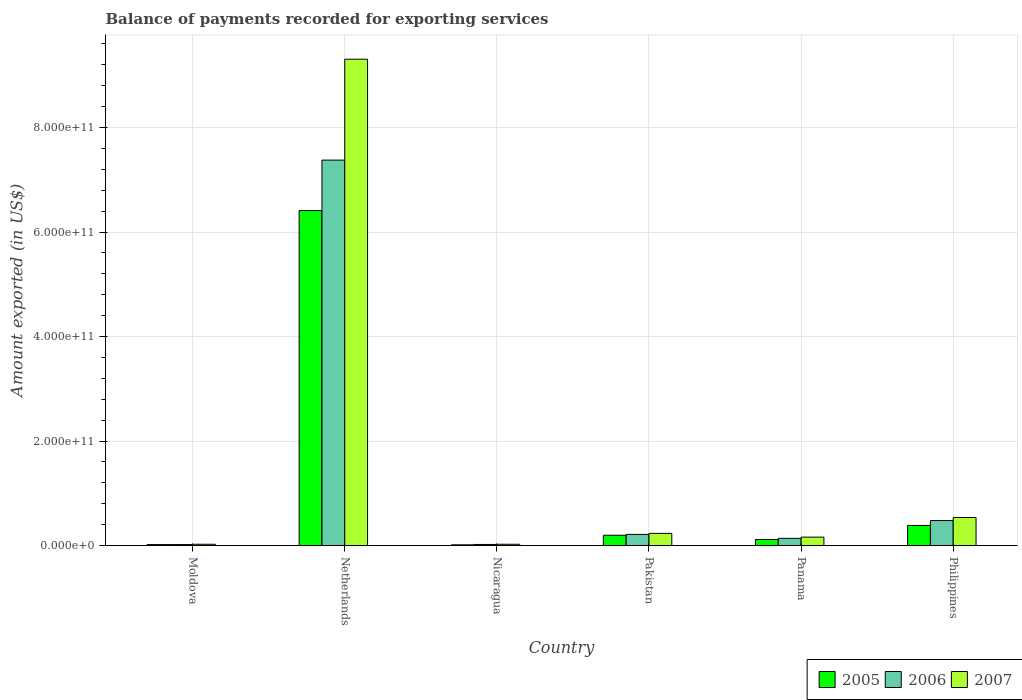How many groups of bars are there?
Make the answer very short. 6. Are the number of bars per tick equal to the number of legend labels?
Make the answer very short. Yes. Are the number of bars on each tick of the X-axis equal?
Ensure brevity in your answer.  Yes. What is the label of the 1st group of bars from the left?
Keep it short and to the point. Moldova. What is the amount exported in 2005 in Netherlands?
Ensure brevity in your answer.  6.41e+11. Across all countries, what is the maximum amount exported in 2006?
Keep it short and to the point. 7.38e+11. Across all countries, what is the minimum amount exported in 2007?
Offer a very short reply. 2.46e+09. In which country was the amount exported in 2007 maximum?
Offer a very short reply. Netherlands. In which country was the amount exported in 2005 minimum?
Keep it short and to the point. Nicaragua. What is the total amount exported in 2005 in the graph?
Provide a short and direct response. 7.14e+11. What is the difference between the amount exported in 2006 in Pakistan and that in Philippines?
Provide a short and direct response. -2.65e+1. What is the difference between the amount exported in 2006 in Nicaragua and the amount exported in 2005 in Moldova?
Your answer should be compact. 2.25e+08. What is the average amount exported in 2006 per country?
Offer a terse response. 1.37e+11. What is the difference between the amount exported of/in 2006 and amount exported of/in 2007 in Nicaragua?
Give a very brief answer. -3.72e+08. In how many countries, is the amount exported in 2007 greater than 40000000000 US$?
Make the answer very short. 2. What is the ratio of the amount exported in 2005 in Pakistan to that in Philippines?
Make the answer very short. 0.51. What is the difference between the highest and the second highest amount exported in 2007?
Offer a very short reply. 8.77e+11. What is the difference between the highest and the lowest amount exported in 2007?
Make the answer very short. 9.28e+11. In how many countries, is the amount exported in 2007 greater than the average amount exported in 2007 taken over all countries?
Offer a very short reply. 1. Is the sum of the amount exported in 2005 in Panama and Philippines greater than the maximum amount exported in 2006 across all countries?
Offer a terse response. No. What is the difference between two consecutive major ticks on the Y-axis?
Your answer should be very brief. 2.00e+11. Does the graph contain any zero values?
Provide a succinct answer. No. Does the graph contain grids?
Your response must be concise. Yes. How many legend labels are there?
Provide a succinct answer. 3. How are the legend labels stacked?
Give a very brief answer. Horizontal. What is the title of the graph?
Ensure brevity in your answer.  Balance of payments recorded for exporting services. Does "1987" appear as one of the legend labels in the graph?
Offer a terse response. No. What is the label or title of the X-axis?
Your answer should be compact. Country. What is the label or title of the Y-axis?
Offer a very short reply. Amount exported (in US$). What is the Amount exported (in US$) of 2005 in Moldova?
Your answer should be compact. 1.87e+09. What is the Amount exported (in US$) of 2006 in Moldova?
Your response must be concise. 1.93e+09. What is the Amount exported (in US$) of 2007 in Moldova?
Offer a very short reply. 2.46e+09. What is the Amount exported (in US$) in 2005 in Netherlands?
Your answer should be very brief. 6.41e+11. What is the Amount exported (in US$) of 2006 in Netherlands?
Offer a very short reply. 7.38e+11. What is the Amount exported (in US$) of 2007 in Netherlands?
Provide a succinct answer. 9.31e+11. What is the Amount exported (in US$) in 2005 in Nicaragua?
Offer a very short reply. 1.43e+09. What is the Amount exported (in US$) of 2006 in Nicaragua?
Give a very brief answer. 2.10e+09. What is the Amount exported (in US$) of 2007 in Nicaragua?
Offer a very short reply. 2.47e+09. What is the Amount exported (in US$) of 2005 in Pakistan?
Provide a short and direct response. 1.98e+1. What is the Amount exported (in US$) in 2006 in Pakistan?
Ensure brevity in your answer.  2.14e+1. What is the Amount exported (in US$) of 2007 in Pakistan?
Your answer should be compact. 2.33e+1. What is the Amount exported (in US$) of 2005 in Panama?
Keep it short and to the point. 1.16e+1. What is the Amount exported (in US$) of 2006 in Panama?
Give a very brief answer. 1.38e+1. What is the Amount exported (in US$) in 2007 in Panama?
Your response must be concise. 1.61e+1. What is the Amount exported (in US$) in 2005 in Philippines?
Give a very brief answer. 3.85e+1. What is the Amount exported (in US$) in 2006 in Philippines?
Offer a terse response. 4.79e+1. What is the Amount exported (in US$) in 2007 in Philippines?
Provide a short and direct response. 5.37e+1. Across all countries, what is the maximum Amount exported (in US$) in 2005?
Provide a succinct answer. 6.41e+11. Across all countries, what is the maximum Amount exported (in US$) in 2006?
Offer a very short reply. 7.38e+11. Across all countries, what is the maximum Amount exported (in US$) in 2007?
Provide a short and direct response. 9.31e+11. Across all countries, what is the minimum Amount exported (in US$) in 2005?
Your response must be concise. 1.43e+09. Across all countries, what is the minimum Amount exported (in US$) of 2006?
Provide a succinct answer. 1.93e+09. Across all countries, what is the minimum Amount exported (in US$) of 2007?
Offer a very short reply. 2.46e+09. What is the total Amount exported (in US$) in 2005 in the graph?
Ensure brevity in your answer.  7.14e+11. What is the total Amount exported (in US$) in 2006 in the graph?
Your response must be concise. 8.25e+11. What is the total Amount exported (in US$) of 2007 in the graph?
Offer a terse response. 1.03e+12. What is the difference between the Amount exported (in US$) in 2005 in Moldova and that in Netherlands?
Your response must be concise. -6.39e+11. What is the difference between the Amount exported (in US$) of 2006 in Moldova and that in Netherlands?
Give a very brief answer. -7.36e+11. What is the difference between the Amount exported (in US$) in 2007 in Moldova and that in Netherlands?
Provide a succinct answer. -9.28e+11. What is the difference between the Amount exported (in US$) in 2005 in Moldova and that in Nicaragua?
Give a very brief answer. 4.38e+08. What is the difference between the Amount exported (in US$) of 2006 in Moldova and that in Nicaragua?
Your answer should be very brief. -1.69e+08. What is the difference between the Amount exported (in US$) in 2007 in Moldova and that in Nicaragua?
Give a very brief answer. -1.36e+07. What is the difference between the Amount exported (in US$) in 2005 in Moldova and that in Pakistan?
Offer a terse response. -1.79e+1. What is the difference between the Amount exported (in US$) of 2006 in Moldova and that in Pakistan?
Make the answer very short. -1.95e+1. What is the difference between the Amount exported (in US$) in 2007 in Moldova and that in Pakistan?
Offer a terse response. -2.08e+1. What is the difference between the Amount exported (in US$) of 2005 in Moldova and that in Panama?
Ensure brevity in your answer.  -9.75e+09. What is the difference between the Amount exported (in US$) in 2006 in Moldova and that in Panama?
Provide a succinct answer. -1.19e+1. What is the difference between the Amount exported (in US$) of 2007 in Moldova and that in Panama?
Offer a very short reply. -1.37e+1. What is the difference between the Amount exported (in US$) of 2005 in Moldova and that in Philippines?
Your response must be concise. -3.66e+1. What is the difference between the Amount exported (in US$) of 2006 in Moldova and that in Philippines?
Make the answer very short. -4.59e+1. What is the difference between the Amount exported (in US$) in 2007 in Moldova and that in Philippines?
Keep it short and to the point. -5.12e+1. What is the difference between the Amount exported (in US$) in 2005 in Netherlands and that in Nicaragua?
Your answer should be compact. 6.40e+11. What is the difference between the Amount exported (in US$) in 2006 in Netherlands and that in Nicaragua?
Provide a short and direct response. 7.36e+11. What is the difference between the Amount exported (in US$) of 2007 in Netherlands and that in Nicaragua?
Keep it short and to the point. 9.28e+11. What is the difference between the Amount exported (in US$) in 2005 in Netherlands and that in Pakistan?
Keep it short and to the point. 6.21e+11. What is the difference between the Amount exported (in US$) of 2006 in Netherlands and that in Pakistan?
Keep it short and to the point. 7.16e+11. What is the difference between the Amount exported (in US$) in 2007 in Netherlands and that in Pakistan?
Make the answer very short. 9.08e+11. What is the difference between the Amount exported (in US$) in 2005 in Netherlands and that in Panama?
Offer a terse response. 6.30e+11. What is the difference between the Amount exported (in US$) in 2006 in Netherlands and that in Panama?
Offer a very short reply. 7.24e+11. What is the difference between the Amount exported (in US$) in 2007 in Netherlands and that in Panama?
Make the answer very short. 9.15e+11. What is the difference between the Amount exported (in US$) of 2005 in Netherlands and that in Philippines?
Give a very brief answer. 6.03e+11. What is the difference between the Amount exported (in US$) in 2006 in Netherlands and that in Philippines?
Give a very brief answer. 6.90e+11. What is the difference between the Amount exported (in US$) in 2007 in Netherlands and that in Philippines?
Offer a terse response. 8.77e+11. What is the difference between the Amount exported (in US$) in 2005 in Nicaragua and that in Pakistan?
Offer a very short reply. -1.83e+1. What is the difference between the Amount exported (in US$) of 2006 in Nicaragua and that in Pakistan?
Make the answer very short. -1.93e+1. What is the difference between the Amount exported (in US$) of 2007 in Nicaragua and that in Pakistan?
Give a very brief answer. -2.08e+1. What is the difference between the Amount exported (in US$) of 2005 in Nicaragua and that in Panama?
Make the answer very short. -1.02e+1. What is the difference between the Amount exported (in US$) of 2006 in Nicaragua and that in Panama?
Provide a short and direct response. -1.17e+1. What is the difference between the Amount exported (in US$) in 2007 in Nicaragua and that in Panama?
Your response must be concise. -1.37e+1. What is the difference between the Amount exported (in US$) in 2005 in Nicaragua and that in Philippines?
Provide a short and direct response. -3.71e+1. What is the difference between the Amount exported (in US$) in 2006 in Nicaragua and that in Philippines?
Provide a short and direct response. -4.58e+1. What is the difference between the Amount exported (in US$) of 2007 in Nicaragua and that in Philippines?
Offer a terse response. -5.12e+1. What is the difference between the Amount exported (in US$) in 2005 in Pakistan and that in Panama?
Your response must be concise. 8.14e+09. What is the difference between the Amount exported (in US$) in 2006 in Pakistan and that in Panama?
Provide a succinct answer. 7.56e+09. What is the difference between the Amount exported (in US$) of 2007 in Pakistan and that in Panama?
Your answer should be compact. 7.18e+09. What is the difference between the Amount exported (in US$) of 2005 in Pakistan and that in Philippines?
Provide a short and direct response. -1.88e+1. What is the difference between the Amount exported (in US$) in 2006 in Pakistan and that in Philippines?
Make the answer very short. -2.65e+1. What is the difference between the Amount exported (in US$) of 2007 in Pakistan and that in Philippines?
Keep it short and to the point. -3.04e+1. What is the difference between the Amount exported (in US$) of 2005 in Panama and that in Philippines?
Make the answer very short. -2.69e+1. What is the difference between the Amount exported (in US$) in 2006 in Panama and that in Philippines?
Provide a short and direct response. -3.40e+1. What is the difference between the Amount exported (in US$) in 2007 in Panama and that in Philippines?
Ensure brevity in your answer.  -3.76e+1. What is the difference between the Amount exported (in US$) of 2005 in Moldova and the Amount exported (in US$) of 2006 in Netherlands?
Make the answer very short. -7.36e+11. What is the difference between the Amount exported (in US$) in 2005 in Moldova and the Amount exported (in US$) in 2007 in Netherlands?
Your response must be concise. -9.29e+11. What is the difference between the Amount exported (in US$) in 2006 in Moldova and the Amount exported (in US$) in 2007 in Netherlands?
Your answer should be compact. -9.29e+11. What is the difference between the Amount exported (in US$) in 2005 in Moldova and the Amount exported (in US$) in 2006 in Nicaragua?
Keep it short and to the point. -2.25e+08. What is the difference between the Amount exported (in US$) of 2005 in Moldova and the Amount exported (in US$) of 2007 in Nicaragua?
Provide a short and direct response. -5.98e+08. What is the difference between the Amount exported (in US$) of 2006 in Moldova and the Amount exported (in US$) of 2007 in Nicaragua?
Your answer should be compact. -5.41e+08. What is the difference between the Amount exported (in US$) in 2005 in Moldova and the Amount exported (in US$) in 2006 in Pakistan?
Offer a very short reply. -1.95e+1. What is the difference between the Amount exported (in US$) in 2005 in Moldova and the Amount exported (in US$) in 2007 in Pakistan?
Offer a terse response. -2.14e+1. What is the difference between the Amount exported (in US$) of 2006 in Moldova and the Amount exported (in US$) of 2007 in Pakistan?
Offer a very short reply. -2.14e+1. What is the difference between the Amount exported (in US$) of 2005 in Moldova and the Amount exported (in US$) of 2006 in Panama?
Offer a very short reply. -1.20e+1. What is the difference between the Amount exported (in US$) in 2005 in Moldova and the Amount exported (in US$) in 2007 in Panama?
Give a very brief answer. -1.43e+1. What is the difference between the Amount exported (in US$) of 2006 in Moldova and the Amount exported (in US$) of 2007 in Panama?
Make the answer very short. -1.42e+1. What is the difference between the Amount exported (in US$) of 2005 in Moldova and the Amount exported (in US$) of 2006 in Philippines?
Ensure brevity in your answer.  -4.60e+1. What is the difference between the Amount exported (in US$) in 2005 in Moldova and the Amount exported (in US$) in 2007 in Philippines?
Offer a very short reply. -5.18e+1. What is the difference between the Amount exported (in US$) in 2006 in Moldova and the Amount exported (in US$) in 2007 in Philippines?
Offer a very short reply. -5.18e+1. What is the difference between the Amount exported (in US$) of 2005 in Netherlands and the Amount exported (in US$) of 2006 in Nicaragua?
Make the answer very short. 6.39e+11. What is the difference between the Amount exported (in US$) in 2005 in Netherlands and the Amount exported (in US$) in 2007 in Nicaragua?
Keep it short and to the point. 6.39e+11. What is the difference between the Amount exported (in US$) of 2006 in Netherlands and the Amount exported (in US$) of 2007 in Nicaragua?
Your answer should be very brief. 7.35e+11. What is the difference between the Amount exported (in US$) in 2005 in Netherlands and the Amount exported (in US$) in 2006 in Pakistan?
Your answer should be compact. 6.20e+11. What is the difference between the Amount exported (in US$) of 2005 in Netherlands and the Amount exported (in US$) of 2007 in Pakistan?
Your answer should be compact. 6.18e+11. What is the difference between the Amount exported (in US$) of 2006 in Netherlands and the Amount exported (in US$) of 2007 in Pakistan?
Make the answer very short. 7.14e+11. What is the difference between the Amount exported (in US$) of 2005 in Netherlands and the Amount exported (in US$) of 2006 in Panama?
Provide a succinct answer. 6.27e+11. What is the difference between the Amount exported (in US$) in 2005 in Netherlands and the Amount exported (in US$) in 2007 in Panama?
Offer a very short reply. 6.25e+11. What is the difference between the Amount exported (in US$) in 2006 in Netherlands and the Amount exported (in US$) in 2007 in Panama?
Your answer should be compact. 7.22e+11. What is the difference between the Amount exported (in US$) in 2005 in Netherlands and the Amount exported (in US$) in 2006 in Philippines?
Keep it short and to the point. 5.93e+11. What is the difference between the Amount exported (in US$) in 2005 in Netherlands and the Amount exported (in US$) in 2007 in Philippines?
Your answer should be very brief. 5.87e+11. What is the difference between the Amount exported (in US$) in 2006 in Netherlands and the Amount exported (in US$) in 2007 in Philippines?
Make the answer very short. 6.84e+11. What is the difference between the Amount exported (in US$) of 2005 in Nicaragua and the Amount exported (in US$) of 2006 in Pakistan?
Give a very brief answer. -2.00e+1. What is the difference between the Amount exported (in US$) in 2005 in Nicaragua and the Amount exported (in US$) in 2007 in Pakistan?
Ensure brevity in your answer.  -2.19e+1. What is the difference between the Amount exported (in US$) in 2006 in Nicaragua and the Amount exported (in US$) in 2007 in Pakistan?
Your response must be concise. -2.12e+1. What is the difference between the Amount exported (in US$) in 2005 in Nicaragua and the Amount exported (in US$) in 2006 in Panama?
Provide a succinct answer. -1.24e+1. What is the difference between the Amount exported (in US$) of 2005 in Nicaragua and the Amount exported (in US$) of 2007 in Panama?
Your answer should be very brief. -1.47e+1. What is the difference between the Amount exported (in US$) of 2006 in Nicaragua and the Amount exported (in US$) of 2007 in Panama?
Provide a succinct answer. -1.40e+1. What is the difference between the Amount exported (in US$) of 2005 in Nicaragua and the Amount exported (in US$) of 2006 in Philippines?
Provide a short and direct response. -4.64e+1. What is the difference between the Amount exported (in US$) in 2005 in Nicaragua and the Amount exported (in US$) in 2007 in Philippines?
Keep it short and to the point. -5.23e+1. What is the difference between the Amount exported (in US$) of 2006 in Nicaragua and the Amount exported (in US$) of 2007 in Philippines?
Keep it short and to the point. -5.16e+1. What is the difference between the Amount exported (in US$) in 2005 in Pakistan and the Amount exported (in US$) in 2006 in Panama?
Provide a succinct answer. 5.91e+09. What is the difference between the Amount exported (in US$) in 2005 in Pakistan and the Amount exported (in US$) in 2007 in Panama?
Offer a very short reply. 3.64e+09. What is the difference between the Amount exported (in US$) of 2006 in Pakistan and the Amount exported (in US$) of 2007 in Panama?
Make the answer very short. 5.28e+09. What is the difference between the Amount exported (in US$) of 2005 in Pakistan and the Amount exported (in US$) of 2006 in Philippines?
Give a very brief answer. -2.81e+1. What is the difference between the Amount exported (in US$) of 2005 in Pakistan and the Amount exported (in US$) of 2007 in Philippines?
Make the answer very short. -3.39e+1. What is the difference between the Amount exported (in US$) in 2006 in Pakistan and the Amount exported (in US$) in 2007 in Philippines?
Make the answer very short. -3.23e+1. What is the difference between the Amount exported (in US$) of 2005 in Panama and the Amount exported (in US$) of 2006 in Philippines?
Your answer should be compact. -3.63e+1. What is the difference between the Amount exported (in US$) of 2005 in Panama and the Amount exported (in US$) of 2007 in Philippines?
Keep it short and to the point. -4.21e+1. What is the difference between the Amount exported (in US$) in 2006 in Panama and the Amount exported (in US$) in 2007 in Philippines?
Offer a very short reply. -3.99e+1. What is the average Amount exported (in US$) of 2005 per country?
Give a very brief answer. 1.19e+11. What is the average Amount exported (in US$) in 2006 per country?
Provide a succinct answer. 1.37e+11. What is the average Amount exported (in US$) in 2007 per country?
Offer a very short reply. 1.71e+11. What is the difference between the Amount exported (in US$) of 2005 and Amount exported (in US$) of 2006 in Moldova?
Provide a short and direct response. -5.65e+07. What is the difference between the Amount exported (in US$) in 2005 and Amount exported (in US$) in 2007 in Moldova?
Make the answer very short. -5.84e+08. What is the difference between the Amount exported (in US$) of 2006 and Amount exported (in US$) of 2007 in Moldova?
Offer a terse response. -5.28e+08. What is the difference between the Amount exported (in US$) of 2005 and Amount exported (in US$) of 2006 in Netherlands?
Your answer should be very brief. -9.66e+1. What is the difference between the Amount exported (in US$) of 2005 and Amount exported (in US$) of 2007 in Netherlands?
Give a very brief answer. -2.90e+11. What is the difference between the Amount exported (in US$) of 2006 and Amount exported (in US$) of 2007 in Netherlands?
Give a very brief answer. -1.93e+11. What is the difference between the Amount exported (in US$) of 2005 and Amount exported (in US$) of 2006 in Nicaragua?
Your answer should be very brief. -6.63e+08. What is the difference between the Amount exported (in US$) in 2005 and Amount exported (in US$) in 2007 in Nicaragua?
Make the answer very short. -1.04e+09. What is the difference between the Amount exported (in US$) in 2006 and Amount exported (in US$) in 2007 in Nicaragua?
Your answer should be very brief. -3.72e+08. What is the difference between the Amount exported (in US$) in 2005 and Amount exported (in US$) in 2006 in Pakistan?
Provide a succinct answer. -1.64e+09. What is the difference between the Amount exported (in US$) in 2005 and Amount exported (in US$) in 2007 in Pakistan?
Give a very brief answer. -3.54e+09. What is the difference between the Amount exported (in US$) in 2006 and Amount exported (in US$) in 2007 in Pakistan?
Provide a succinct answer. -1.90e+09. What is the difference between the Amount exported (in US$) in 2005 and Amount exported (in US$) in 2006 in Panama?
Offer a very short reply. -2.23e+09. What is the difference between the Amount exported (in US$) of 2005 and Amount exported (in US$) of 2007 in Panama?
Offer a very short reply. -4.51e+09. What is the difference between the Amount exported (in US$) in 2006 and Amount exported (in US$) in 2007 in Panama?
Your answer should be very brief. -2.28e+09. What is the difference between the Amount exported (in US$) in 2005 and Amount exported (in US$) in 2006 in Philippines?
Your answer should be compact. -9.36e+09. What is the difference between the Amount exported (in US$) of 2005 and Amount exported (in US$) of 2007 in Philippines?
Offer a very short reply. -1.52e+1. What is the difference between the Amount exported (in US$) of 2006 and Amount exported (in US$) of 2007 in Philippines?
Your response must be concise. -5.82e+09. What is the ratio of the Amount exported (in US$) of 2005 in Moldova to that in Netherlands?
Give a very brief answer. 0. What is the ratio of the Amount exported (in US$) in 2006 in Moldova to that in Netherlands?
Your response must be concise. 0. What is the ratio of the Amount exported (in US$) in 2007 in Moldova to that in Netherlands?
Provide a short and direct response. 0. What is the ratio of the Amount exported (in US$) in 2005 in Moldova to that in Nicaragua?
Provide a succinct answer. 1.31. What is the ratio of the Amount exported (in US$) in 2006 in Moldova to that in Nicaragua?
Your response must be concise. 0.92. What is the ratio of the Amount exported (in US$) of 2007 in Moldova to that in Nicaragua?
Offer a terse response. 0.99. What is the ratio of the Amount exported (in US$) in 2005 in Moldova to that in Pakistan?
Offer a very short reply. 0.09. What is the ratio of the Amount exported (in US$) in 2006 in Moldova to that in Pakistan?
Your answer should be very brief. 0.09. What is the ratio of the Amount exported (in US$) in 2007 in Moldova to that in Pakistan?
Ensure brevity in your answer.  0.11. What is the ratio of the Amount exported (in US$) in 2005 in Moldova to that in Panama?
Offer a terse response. 0.16. What is the ratio of the Amount exported (in US$) in 2006 in Moldova to that in Panama?
Your response must be concise. 0.14. What is the ratio of the Amount exported (in US$) in 2007 in Moldova to that in Panama?
Provide a succinct answer. 0.15. What is the ratio of the Amount exported (in US$) in 2005 in Moldova to that in Philippines?
Offer a terse response. 0.05. What is the ratio of the Amount exported (in US$) of 2006 in Moldova to that in Philippines?
Offer a terse response. 0.04. What is the ratio of the Amount exported (in US$) in 2007 in Moldova to that in Philippines?
Make the answer very short. 0.05. What is the ratio of the Amount exported (in US$) of 2005 in Netherlands to that in Nicaragua?
Your answer should be compact. 447.17. What is the ratio of the Amount exported (in US$) of 2006 in Netherlands to that in Nicaragua?
Provide a short and direct response. 351.89. What is the ratio of the Amount exported (in US$) of 2007 in Netherlands to that in Nicaragua?
Ensure brevity in your answer.  377.02. What is the ratio of the Amount exported (in US$) of 2005 in Netherlands to that in Pakistan?
Offer a very short reply. 32.45. What is the ratio of the Amount exported (in US$) in 2006 in Netherlands to that in Pakistan?
Offer a very short reply. 34.47. What is the ratio of the Amount exported (in US$) of 2007 in Netherlands to that in Pakistan?
Your answer should be compact. 39.95. What is the ratio of the Amount exported (in US$) in 2005 in Netherlands to that in Panama?
Keep it short and to the point. 55.18. What is the ratio of the Amount exported (in US$) in 2006 in Netherlands to that in Panama?
Offer a very short reply. 53.28. What is the ratio of the Amount exported (in US$) in 2007 in Netherlands to that in Panama?
Ensure brevity in your answer.  57.73. What is the ratio of the Amount exported (in US$) in 2005 in Netherlands to that in Philippines?
Your answer should be compact. 16.65. What is the ratio of the Amount exported (in US$) in 2006 in Netherlands to that in Philippines?
Ensure brevity in your answer.  15.41. What is the ratio of the Amount exported (in US$) of 2007 in Netherlands to that in Philippines?
Keep it short and to the point. 17.34. What is the ratio of the Amount exported (in US$) of 2005 in Nicaragua to that in Pakistan?
Provide a succinct answer. 0.07. What is the ratio of the Amount exported (in US$) of 2006 in Nicaragua to that in Pakistan?
Keep it short and to the point. 0.1. What is the ratio of the Amount exported (in US$) in 2007 in Nicaragua to that in Pakistan?
Offer a terse response. 0.11. What is the ratio of the Amount exported (in US$) of 2005 in Nicaragua to that in Panama?
Provide a short and direct response. 0.12. What is the ratio of the Amount exported (in US$) in 2006 in Nicaragua to that in Panama?
Ensure brevity in your answer.  0.15. What is the ratio of the Amount exported (in US$) of 2007 in Nicaragua to that in Panama?
Give a very brief answer. 0.15. What is the ratio of the Amount exported (in US$) in 2005 in Nicaragua to that in Philippines?
Make the answer very short. 0.04. What is the ratio of the Amount exported (in US$) in 2006 in Nicaragua to that in Philippines?
Make the answer very short. 0.04. What is the ratio of the Amount exported (in US$) in 2007 in Nicaragua to that in Philippines?
Offer a terse response. 0.05. What is the ratio of the Amount exported (in US$) in 2005 in Pakistan to that in Panama?
Provide a succinct answer. 1.7. What is the ratio of the Amount exported (in US$) of 2006 in Pakistan to that in Panama?
Give a very brief answer. 1.55. What is the ratio of the Amount exported (in US$) of 2007 in Pakistan to that in Panama?
Offer a very short reply. 1.45. What is the ratio of the Amount exported (in US$) of 2005 in Pakistan to that in Philippines?
Your answer should be very brief. 0.51. What is the ratio of the Amount exported (in US$) in 2006 in Pakistan to that in Philippines?
Give a very brief answer. 0.45. What is the ratio of the Amount exported (in US$) of 2007 in Pakistan to that in Philippines?
Make the answer very short. 0.43. What is the ratio of the Amount exported (in US$) of 2005 in Panama to that in Philippines?
Ensure brevity in your answer.  0.3. What is the ratio of the Amount exported (in US$) in 2006 in Panama to that in Philippines?
Provide a short and direct response. 0.29. What is the ratio of the Amount exported (in US$) of 2007 in Panama to that in Philippines?
Offer a very short reply. 0.3. What is the difference between the highest and the second highest Amount exported (in US$) in 2005?
Ensure brevity in your answer.  6.03e+11. What is the difference between the highest and the second highest Amount exported (in US$) of 2006?
Make the answer very short. 6.90e+11. What is the difference between the highest and the second highest Amount exported (in US$) in 2007?
Give a very brief answer. 8.77e+11. What is the difference between the highest and the lowest Amount exported (in US$) in 2005?
Make the answer very short. 6.40e+11. What is the difference between the highest and the lowest Amount exported (in US$) in 2006?
Your answer should be compact. 7.36e+11. What is the difference between the highest and the lowest Amount exported (in US$) in 2007?
Offer a very short reply. 9.28e+11. 